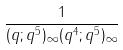Convert formula to latex. <formula><loc_0><loc_0><loc_500><loc_500>\frac { 1 } { ( q ; q ^ { 5 } ) _ { \infty } ( q ^ { 4 } ; q ^ { 5 } ) _ { \infty } }</formula> 